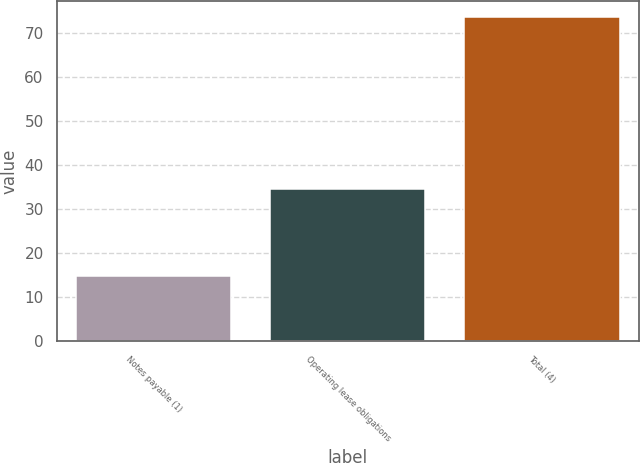<chart> <loc_0><loc_0><loc_500><loc_500><bar_chart><fcel>Notes payable (1)<fcel>Operating lease obligations<fcel>Total (4)<nl><fcel>14.9<fcel>34.5<fcel>73.5<nl></chart> 